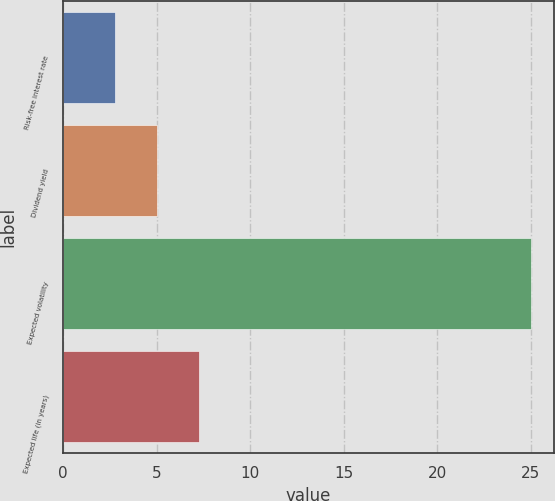<chart> <loc_0><loc_0><loc_500><loc_500><bar_chart><fcel>Risk-free interest rate<fcel>Dividend yield<fcel>Expected volatility<fcel>Expected life (in years)<nl><fcel>2.8<fcel>5.02<fcel>25<fcel>7.24<nl></chart> 